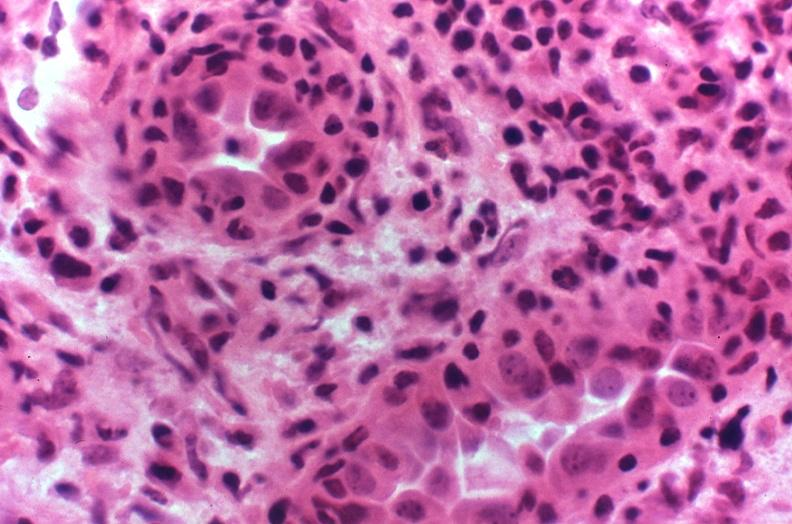where is this?
Answer the question using a single word or phrase. Urinary 